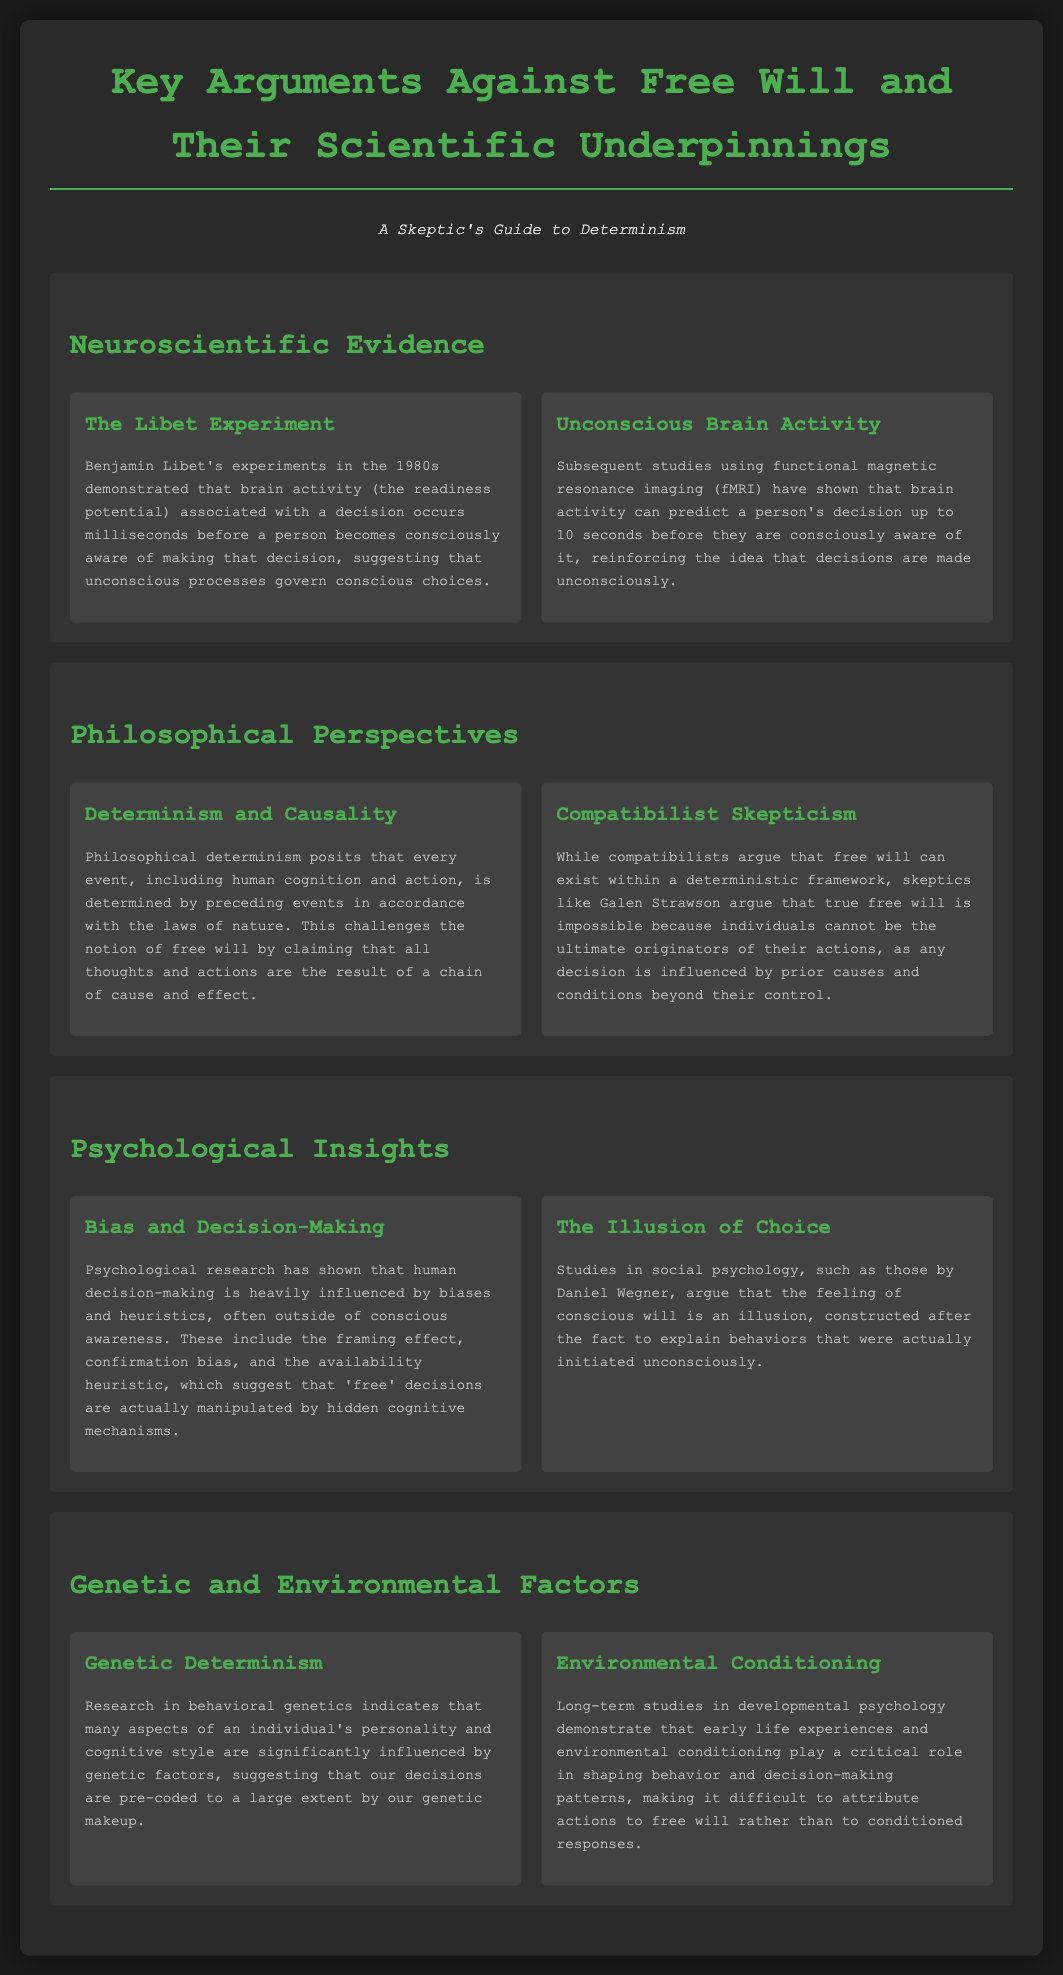What is the title of the document? The title of the document is provided in the header, which is "Key Arguments Against Free Will and Their Scientific Underpinnings".
Answer: Key Arguments Against Free Will and Their Scientific Underpinnings Who conducted the Libet Experiment? The Libet Experiment was conducted by Benjamin Libet in the 1980s.
Answer: Benjamin Libet What does the "readiness potential" refer to? The "readiness potential" refers to brain activity associated with a decision that occurs before conscious awareness.
Answer: Brain activity associated with a decision How long before conscious awareness can brain activity predict decisions? Brain activity has been shown to predict decisions up to 10 seconds before conscious awareness.
Answer: 10 seconds What philosophical position challenges the idea of free will by linking thoughts to a chain of cause and effect? The philosophical position that challenges the notion of free will by linking thoughts to causality is called determinism.
Answer: Determinism What form of skepticism does Galen Strawson represent? Galen Strawson represents compatibilist skepticism regarding the possibility of true free will.
Answer: Compatibilist skepticism Which psychological factors influence human decision-making? Human decision-making is influenced by biases, heuristics, and cognitive mechanisms.
Answer: Biases and heuristics What does research in behavioral genetics indicate about personality? Research in behavioral genetics indicates that personality is significantly influenced by genetic factors.
Answer: Genetic factors What role do early life experiences play according to developmental psychology studies? Early life experiences play a critical role in shaping behavior and decision-making patterns.
Answer: Shaping behavior and decision-making patterns 